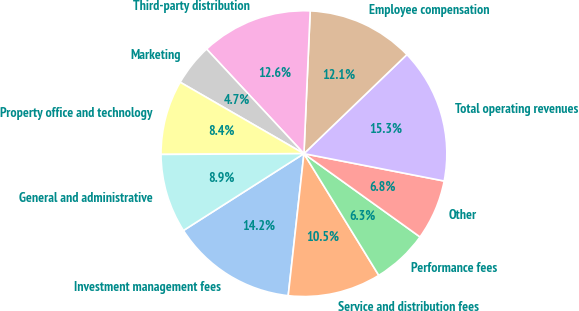<chart> <loc_0><loc_0><loc_500><loc_500><pie_chart><fcel>Investment management fees<fcel>Service and distribution fees<fcel>Performance fees<fcel>Other<fcel>Total operating revenues<fcel>Employee compensation<fcel>Third-party distribution<fcel>Marketing<fcel>Property office and technology<fcel>General and administrative<nl><fcel>14.21%<fcel>10.53%<fcel>6.32%<fcel>6.84%<fcel>15.26%<fcel>12.11%<fcel>12.63%<fcel>4.74%<fcel>8.42%<fcel>8.95%<nl></chart> 